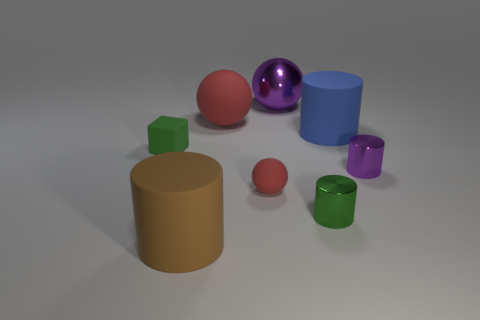How many red balls must be subtracted to get 1 red balls? 1 Subtract all blue rubber cylinders. How many cylinders are left? 3 Add 2 large yellow spheres. How many objects exist? 10 Subtract all purple spheres. How many spheres are left? 2 Subtract 3 cylinders. How many cylinders are left? 1 Subtract all spheres. How many objects are left? 5 Add 3 tiny green cubes. How many tiny green cubes are left? 4 Add 6 large green rubber objects. How many large green rubber objects exist? 6 Subtract 0 cyan blocks. How many objects are left? 8 Subtract all red balls. Subtract all yellow blocks. How many balls are left? 1 